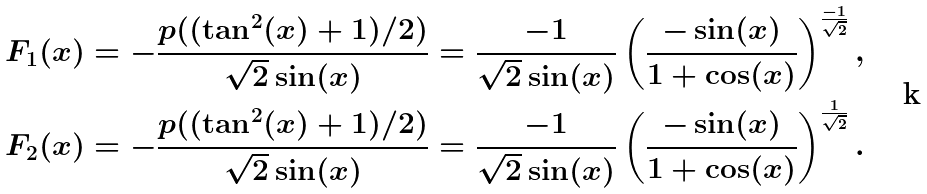Convert formula to latex. <formula><loc_0><loc_0><loc_500><loc_500>F _ { 1 } ( x ) & = - \frac { p ( ( \tan ^ { 2 } ( x ) + 1 ) / 2 ) } { \sqrt { 2 } \sin ( x ) } = \frac { - 1 } { \sqrt { 2 } \sin ( x ) } \left ( \frac { - \sin ( x ) } { 1 + \cos ( x ) } \right ) ^ { \frac { - 1 } { \sqrt { 2 } } } , \\ F _ { 2 } ( x ) & = - \frac { p ( ( \tan ^ { 2 } ( x ) + 1 ) / 2 ) } { \sqrt { 2 } \sin ( x ) } = \frac { - 1 } { \sqrt { 2 } \sin ( x ) } \left ( \frac { - \sin ( x ) } { 1 + \cos ( x ) } \right ) ^ { \frac { 1 } { \sqrt { 2 } } } .</formula> 